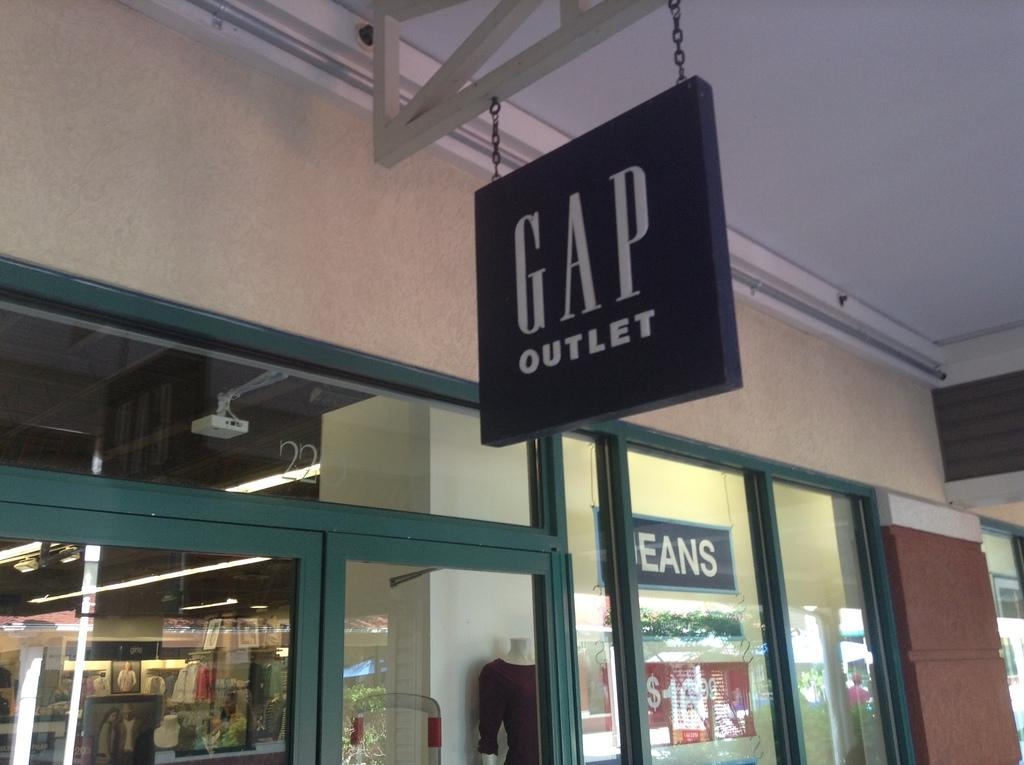What type of structure is visible in the image? There is a building in the image. What is unique about the building's walls? The building has glass walls. Can you describe what is inside the building? Unfortunately, the image does not provide enough detail to determine what is inside the building. How much silver can be seen inside the building in the image? There is no silver visible inside the building in the image, as the image does not provide enough detail to determine the contents of the building. 